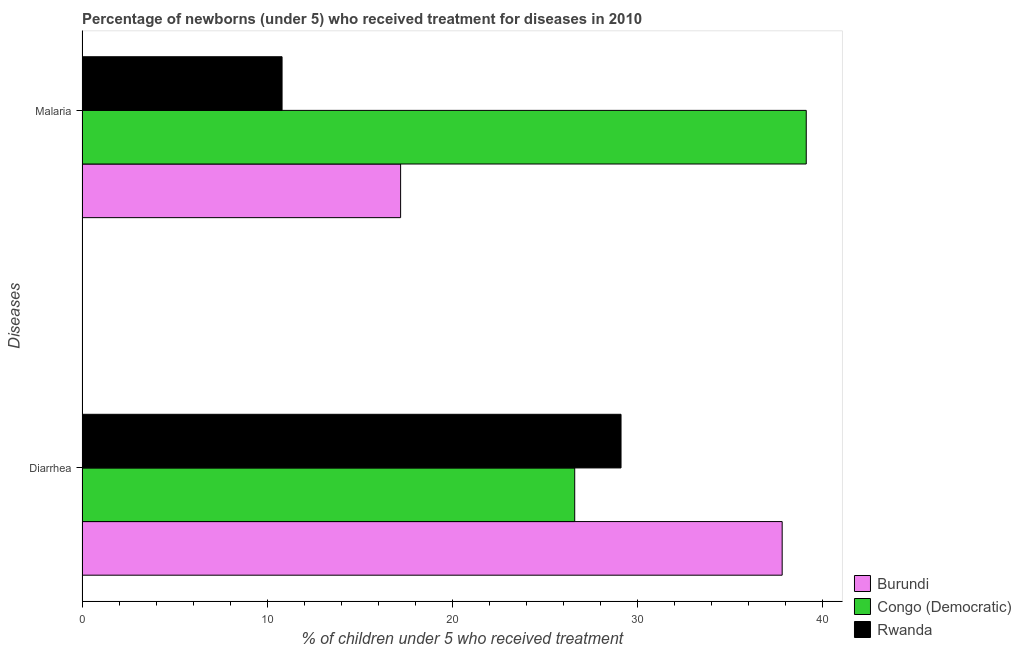How many different coloured bars are there?
Provide a succinct answer. 3. How many groups of bars are there?
Provide a succinct answer. 2. Are the number of bars on each tick of the Y-axis equal?
Provide a succinct answer. Yes. What is the label of the 1st group of bars from the top?
Offer a terse response. Malaria. What is the percentage of children who received treatment for diarrhoea in Burundi?
Provide a short and direct response. 37.8. Across all countries, what is the maximum percentage of children who received treatment for malaria?
Ensure brevity in your answer.  39.1. Across all countries, what is the minimum percentage of children who received treatment for diarrhoea?
Provide a short and direct response. 26.6. In which country was the percentage of children who received treatment for diarrhoea maximum?
Provide a short and direct response. Burundi. In which country was the percentage of children who received treatment for diarrhoea minimum?
Your answer should be very brief. Congo (Democratic). What is the total percentage of children who received treatment for malaria in the graph?
Offer a terse response. 67.1. What is the difference between the percentage of children who received treatment for diarrhoea in Burundi and that in Congo (Democratic)?
Keep it short and to the point. 11.2. What is the difference between the percentage of children who received treatment for diarrhoea in Congo (Democratic) and the percentage of children who received treatment for malaria in Burundi?
Keep it short and to the point. 9.4. What is the average percentage of children who received treatment for diarrhoea per country?
Give a very brief answer. 31.17. What is the difference between the percentage of children who received treatment for malaria and percentage of children who received treatment for diarrhoea in Burundi?
Your response must be concise. -20.6. In how many countries, is the percentage of children who received treatment for malaria greater than 16 %?
Offer a terse response. 2. What is the ratio of the percentage of children who received treatment for diarrhoea in Rwanda to that in Congo (Democratic)?
Offer a very short reply. 1.09. Is the percentage of children who received treatment for diarrhoea in Burundi less than that in Rwanda?
Provide a succinct answer. No. What does the 1st bar from the top in Malaria represents?
Provide a succinct answer. Rwanda. What does the 1st bar from the bottom in Malaria represents?
Ensure brevity in your answer.  Burundi. Are all the bars in the graph horizontal?
Offer a terse response. Yes. What is the difference between two consecutive major ticks on the X-axis?
Provide a succinct answer. 10. How many legend labels are there?
Offer a terse response. 3. What is the title of the graph?
Make the answer very short. Percentage of newborns (under 5) who received treatment for diseases in 2010. What is the label or title of the X-axis?
Make the answer very short. % of children under 5 who received treatment. What is the label or title of the Y-axis?
Your answer should be compact. Diseases. What is the % of children under 5 who received treatment in Burundi in Diarrhea?
Provide a succinct answer. 37.8. What is the % of children under 5 who received treatment in Congo (Democratic) in Diarrhea?
Provide a short and direct response. 26.6. What is the % of children under 5 who received treatment in Rwanda in Diarrhea?
Give a very brief answer. 29.1. What is the % of children under 5 who received treatment of Congo (Democratic) in Malaria?
Your response must be concise. 39.1. Across all Diseases, what is the maximum % of children under 5 who received treatment of Burundi?
Your answer should be compact. 37.8. Across all Diseases, what is the maximum % of children under 5 who received treatment in Congo (Democratic)?
Your answer should be very brief. 39.1. Across all Diseases, what is the maximum % of children under 5 who received treatment of Rwanda?
Ensure brevity in your answer.  29.1. Across all Diseases, what is the minimum % of children under 5 who received treatment in Congo (Democratic)?
Provide a short and direct response. 26.6. Across all Diseases, what is the minimum % of children under 5 who received treatment in Rwanda?
Offer a very short reply. 10.8. What is the total % of children under 5 who received treatment in Burundi in the graph?
Ensure brevity in your answer.  55. What is the total % of children under 5 who received treatment in Congo (Democratic) in the graph?
Provide a succinct answer. 65.7. What is the total % of children under 5 who received treatment in Rwanda in the graph?
Keep it short and to the point. 39.9. What is the difference between the % of children under 5 who received treatment in Burundi in Diarrhea and that in Malaria?
Offer a very short reply. 20.6. What is the difference between the % of children under 5 who received treatment of Rwanda in Diarrhea and that in Malaria?
Your response must be concise. 18.3. What is the difference between the % of children under 5 who received treatment in Burundi in Diarrhea and the % of children under 5 who received treatment in Congo (Democratic) in Malaria?
Make the answer very short. -1.3. What is the difference between the % of children under 5 who received treatment in Burundi in Diarrhea and the % of children under 5 who received treatment in Rwanda in Malaria?
Your response must be concise. 27. What is the average % of children under 5 who received treatment of Congo (Democratic) per Diseases?
Give a very brief answer. 32.85. What is the average % of children under 5 who received treatment in Rwanda per Diseases?
Offer a terse response. 19.95. What is the difference between the % of children under 5 who received treatment of Burundi and % of children under 5 who received treatment of Congo (Democratic) in Diarrhea?
Offer a terse response. 11.2. What is the difference between the % of children under 5 who received treatment in Burundi and % of children under 5 who received treatment in Rwanda in Diarrhea?
Offer a terse response. 8.7. What is the difference between the % of children under 5 who received treatment in Congo (Democratic) and % of children under 5 who received treatment in Rwanda in Diarrhea?
Your answer should be very brief. -2.5. What is the difference between the % of children under 5 who received treatment in Burundi and % of children under 5 who received treatment in Congo (Democratic) in Malaria?
Your response must be concise. -21.9. What is the difference between the % of children under 5 who received treatment of Burundi and % of children under 5 who received treatment of Rwanda in Malaria?
Provide a short and direct response. 6.4. What is the difference between the % of children under 5 who received treatment of Congo (Democratic) and % of children under 5 who received treatment of Rwanda in Malaria?
Offer a very short reply. 28.3. What is the ratio of the % of children under 5 who received treatment of Burundi in Diarrhea to that in Malaria?
Offer a very short reply. 2.2. What is the ratio of the % of children under 5 who received treatment of Congo (Democratic) in Diarrhea to that in Malaria?
Keep it short and to the point. 0.68. What is the ratio of the % of children under 5 who received treatment in Rwanda in Diarrhea to that in Malaria?
Your response must be concise. 2.69. What is the difference between the highest and the second highest % of children under 5 who received treatment in Burundi?
Offer a terse response. 20.6. What is the difference between the highest and the second highest % of children under 5 who received treatment in Rwanda?
Offer a terse response. 18.3. What is the difference between the highest and the lowest % of children under 5 who received treatment of Burundi?
Your answer should be compact. 20.6. What is the difference between the highest and the lowest % of children under 5 who received treatment in Congo (Democratic)?
Your response must be concise. 12.5. What is the difference between the highest and the lowest % of children under 5 who received treatment in Rwanda?
Your answer should be compact. 18.3. 